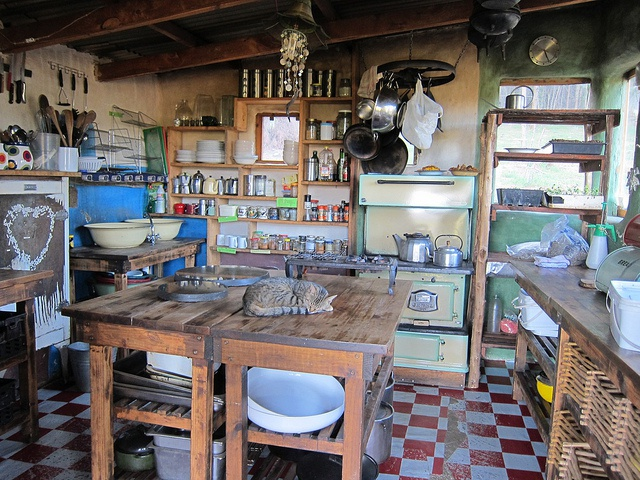Describe the objects in this image and their specific colors. I can see dining table in black, gray, darkgray, and lightblue tones, refrigerator in black, gray, and darkgray tones, bowl in black, lightblue, lavender, and darkgray tones, oven in black, darkgray, lightblue, and gray tones, and bottle in black, darkgray, gray, and lightgray tones in this image. 